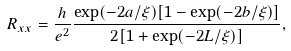Convert formula to latex. <formula><loc_0><loc_0><loc_500><loc_500>R _ { x x } = \frac { h } { e ^ { 2 } } \frac { \exp ( - 2 a / \xi ) [ 1 - \exp ( - 2 b / \xi ) ] } { 2 [ 1 + \exp ( - 2 L / \xi ) ] } ,</formula> 